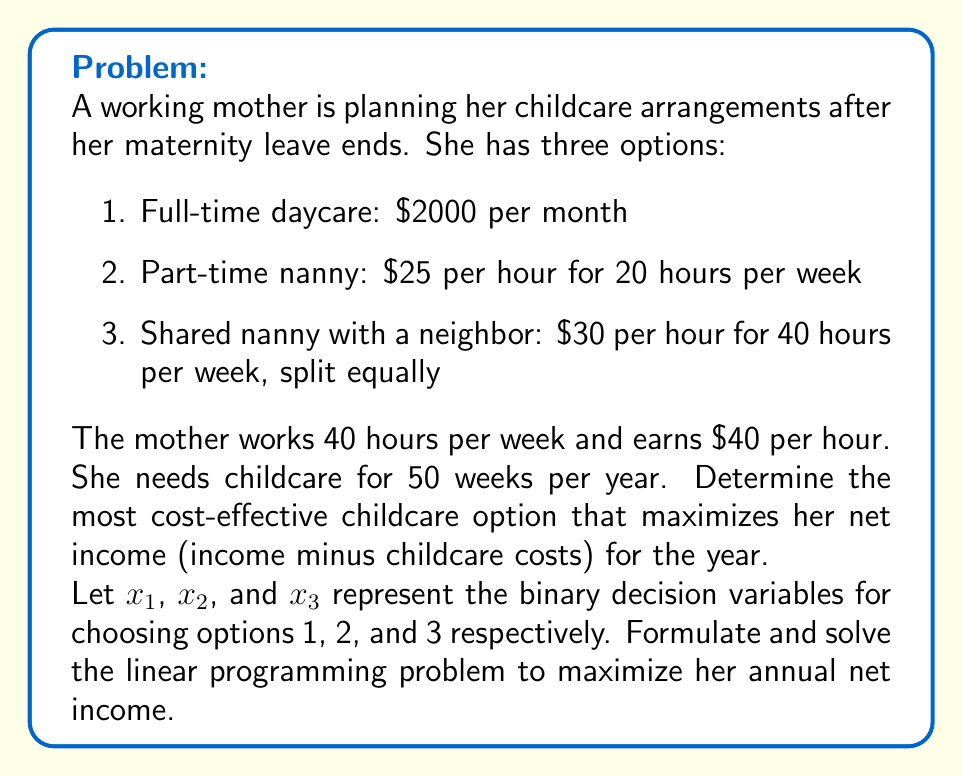Help me with this question. To solve this problem, we need to formulate a linear programming model and then solve it. Let's break it down step by step:

1. Define the objective function:
   Maximize annual net income = Annual income - Annual childcare cost
   
   Annual income = $40 \times 40 \text{ hours} \times 50 \text{ weeks} = $80,000$

2. Set up the constraints:
   $$x_1 + x_2 + x_3 = 1$$ (only one option can be chosen)
   $$x_1, x_2, x_3 \in \{0,1\}$$ (binary decision variables)

3. Calculate annual costs for each option:
   Option 1: $2000 \times 12 \text{ months} = $24,000$ per year
   Option 2: $25 \times 20 \text{ hours} \times 50 \text{ weeks} = $25,000$ per year
   Option 3: $\frac{1}{2} \times $30 \times 40 \text{ hours} \times 50 \text{ weeks} = $30,000$ per year

4. Formulate the objective function:
   Maximize $Z = 80000 - (24000x_1 + 25000x_2 + 30000x_3)$

5. Solve the linear programming problem:
   Since we have binary decision variables and only one can be chosen, we can simply evaluate the objective function for each option:

   Option 1: $Z = 80000 - 24000 = $56,000$
   Option 2: $Z = 80000 - 25000 = $55,000$
   Option 3: $Z = 80000 - 30000 = $50,000$

6. Compare the results:
   The highest value of $Z$ corresponds to the most cost-effective option that maximizes net income.
Answer: The most cost-effective childcare option that maximizes the mother's net income is Option 1: Full-time daycare. This option results in an annual net income of $56,000, which is higher than the other two options. 